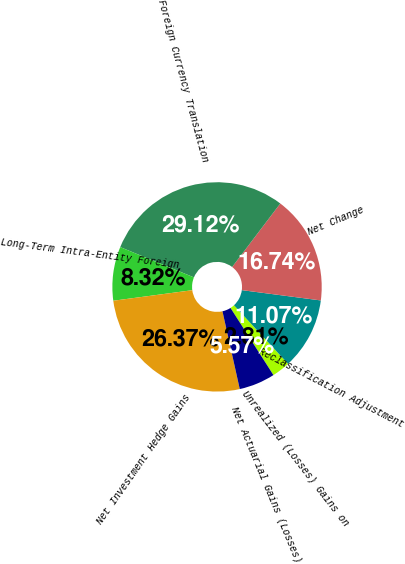Convert chart. <chart><loc_0><loc_0><loc_500><loc_500><pie_chart><fcel>Unrealized (Losses) Gains on<fcel>Reclassification Adjustment<fcel>Net Change<fcel>Foreign Currency Translation<fcel>Long-Term Intra-Entity Foreign<fcel>Net Investment Hedge Gains<fcel>Net Actuarial Gains (Losses)<nl><fcel>2.81%<fcel>11.07%<fcel>16.74%<fcel>29.12%<fcel>8.32%<fcel>26.37%<fcel>5.57%<nl></chart> 